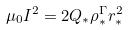<formula> <loc_0><loc_0><loc_500><loc_500>\mu _ { 0 } I ^ { 2 } = 2 Q _ { * } \rho _ { * } ^ { \Gamma } r _ { * } ^ { 2 }</formula> 